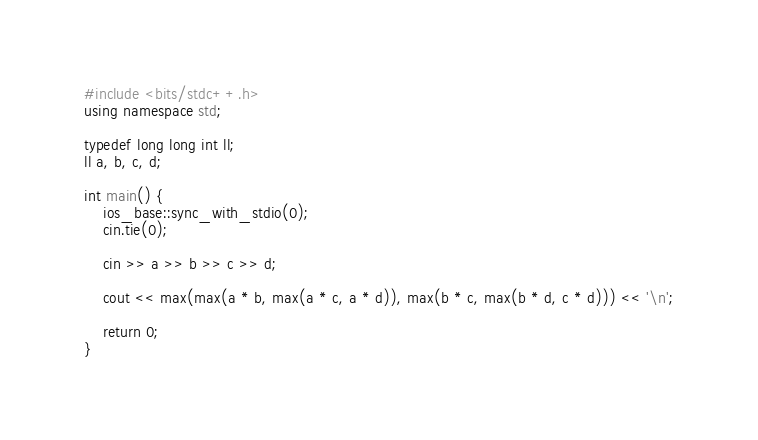<code> <loc_0><loc_0><loc_500><loc_500><_C++_>
#include <bits/stdc++.h>
using namespace std;

typedef long long int ll;
ll a, b, c, d;

int main() {
    ios_base::sync_with_stdio(0);
    cin.tie(0);

    cin >> a >> b >> c >> d;

    cout << max(max(a * b, max(a * c, a * d)), max(b * c, max(b * d, c * d))) << '\n';

    return 0;
}</code> 